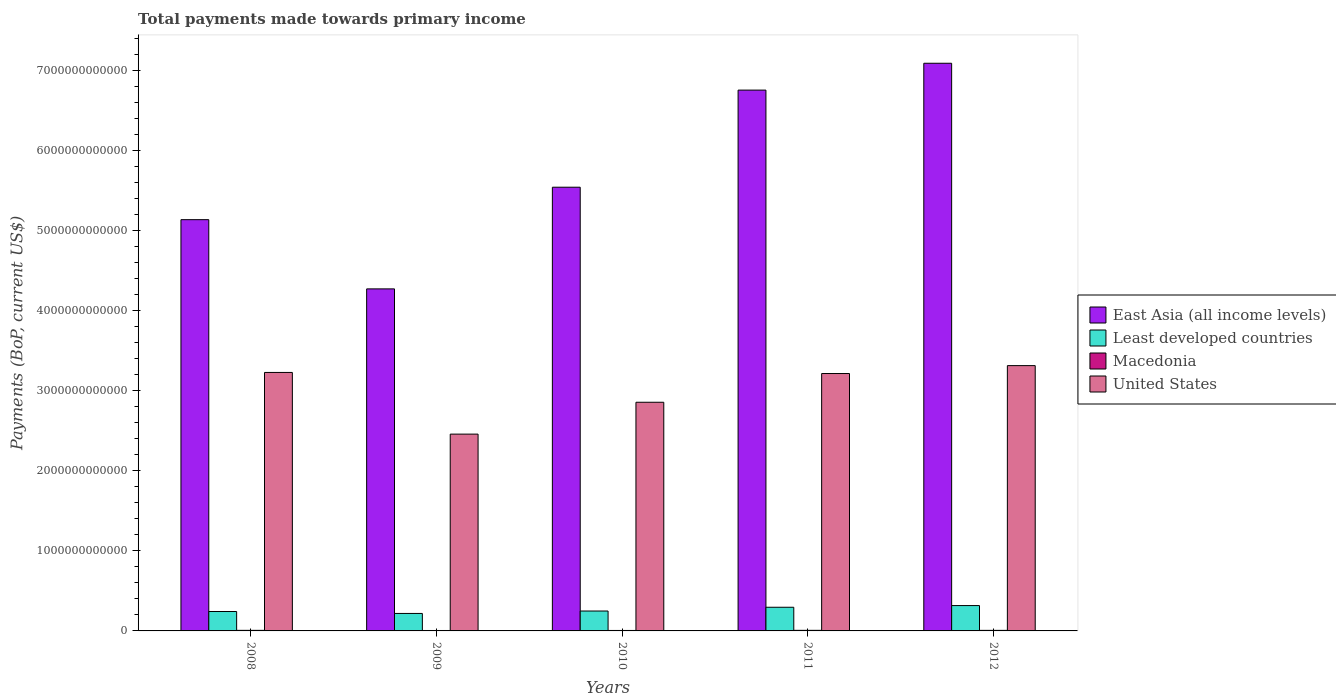Are the number of bars per tick equal to the number of legend labels?
Give a very brief answer. Yes. How many bars are there on the 3rd tick from the left?
Provide a succinct answer. 4. What is the label of the 3rd group of bars from the left?
Give a very brief answer. 2010. What is the total payments made towards primary income in United States in 2012?
Your response must be concise. 3.31e+12. Across all years, what is the maximum total payments made towards primary income in East Asia (all income levels)?
Provide a succinct answer. 7.09e+12. Across all years, what is the minimum total payments made towards primary income in United States?
Ensure brevity in your answer.  2.46e+12. What is the total total payments made towards primary income in East Asia (all income levels) in the graph?
Your answer should be very brief. 2.88e+13. What is the difference between the total payments made towards primary income in East Asia (all income levels) in 2009 and that in 2010?
Offer a very short reply. -1.27e+12. What is the difference between the total payments made towards primary income in United States in 2010 and the total payments made towards primary income in East Asia (all income levels) in 2009?
Give a very brief answer. -1.42e+12. What is the average total payments made towards primary income in United States per year?
Provide a succinct answer. 3.01e+12. In the year 2011, what is the difference between the total payments made towards primary income in Least developed countries and total payments made towards primary income in East Asia (all income levels)?
Offer a very short reply. -6.46e+12. In how many years, is the total payments made towards primary income in United States greater than 4600000000000 US$?
Your answer should be compact. 0. What is the ratio of the total payments made towards primary income in Least developed countries in 2009 to that in 2011?
Make the answer very short. 0.74. Is the total payments made towards primary income in Least developed countries in 2009 less than that in 2012?
Provide a succinct answer. Yes. What is the difference between the highest and the second highest total payments made towards primary income in United States?
Make the answer very short. 8.52e+1. What is the difference between the highest and the lowest total payments made towards primary income in Least developed countries?
Provide a short and direct response. 9.82e+1. Is the sum of the total payments made towards primary income in East Asia (all income levels) in 2008 and 2012 greater than the maximum total payments made towards primary income in Macedonia across all years?
Keep it short and to the point. Yes. Is it the case that in every year, the sum of the total payments made towards primary income in United States and total payments made towards primary income in East Asia (all income levels) is greater than the sum of total payments made towards primary income in Least developed countries and total payments made towards primary income in Macedonia?
Offer a very short reply. No. What does the 1st bar from the left in 2009 represents?
Offer a very short reply. East Asia (all income levels). What does the 4th bar from the right in 2009 represents?
Your answer should be very brief. East Asia (all income levels). Is it the case that in every year, the sum of the total payments made towards primary income in Least developed countries and total payments made towards primary income in Macedonia is greater than the total payments made towards primary income in East Asia (all income levels)?
Ensure brevity in your answer.  No. What is the difference between two consecutive major ticks on the Y-axis?
Your answer should be very brief. 1.00e+12. Are the values on the major ticks of Y-axis written in scientific E-notation?
Offer a very short reply. No. Does the graph contain any zero values?
Provide a succinct answer. No. Does the graph contain grids?
Offer a terse response. No. What is the title of the graph?
Keep it short and to the point. Total payments made towards primary income. Does "East Asia (developing only)" appear as one of the legend labels in the graph?
Keep it short and to the point. No. What is the label or title of the X-axis?
Your response must be concise. Years. What is the label or title of the Y-axis?
Make the answer very short. Payments (BoP, current US$). What is the Payments (BoP, current US$) of East Asia (all income levels) in 2008?
Make the answer very short. 5.14e+12. What is the Payments (BoP, current US$) of Least developed countries in 2008?
Keep it short and to the point. 2.42e+11. What is the Payments (BoP, current US$) of Macedonia in 2008?
Ensure brevity in your answer.  7.21e+09. What is the Payments (BoP, current US$) of United States in 2008?
Give a very brief answer. 3.23e+12. What is the Payments (BoP, current US$) of East Asia (all income levels) in 2009?
Give a very brief answer. 4.27e+12. What is the Payments (BoP, current US$) of Least developed countries in 2009?
Give a very brief answer. 2.18e+11. What is the Payments (BoP, current US$) of Macedonia in 2009?
Your response must be concise. 5.38e+09. What is the Payments (BoP, current US$) of United States in 2009?
Keep it short and to the point. 2.46e+12. What is the Payments (BoP, current US$) in East Asia (all income levels) in 2010?
Keep it short and to the point. 5.54e+12. What is the Payments (BoP, current US$) of Least developed countries in 2010?
Your answer should be very brief. 2.49e+11. What is the Payments (BoP, current US$) in Macedonia in 2010?
Ensure brevity in your answer.  5.79e+09. What is the Payments (BoP, current US$) in United States in 2010?
Offer a terse response. 2.86e+12. What is the Payments (BoP, current US$) in East Asia (all income levels) in 2011?
Offer a terse response. 6.75e+12. What is the Payments (BoP, current US$) in Least developed countries in 2011?
Keep it short and to the point. 2.95e+11. What is the Payments (BoP, current US$) in Macedonia in 2011?
Your answer should be very brief. 7.35e+09. What is the Payments (BoP, current US$) of United States in 2011?
Offer a terse response. 3.21e+12. What is the Payments (BoP, current US$) in East Asia (all income levels) in 2012?
Your answer should be compact. 7.09e+12. What is the Payments (BoP, current US$) of Least developed countries in 2012?
Offer a very short reply. 3.17e+11. What is the Payments (BoP, current US$) in Macedonia in 2012?
Provide a succinct answer. 6.92e+09. What is the Payments (BoP, current US$) of United States in 2012?
Give a very brief answer. 3.31e+12. Across all years, what is the maximum Payments (BoP, current US$) in East Asia (all income levels)?
Keep it short and to the point. 7.09e+12. Across all years, what is the maximum Payments (BoP, current US$) of Least developed countries?
Your answer should be compact. 3.17e+11. Across all years, what is the maximum Payments (BoP, current US$) of Macedonia?
Your response must be concise. 7.35e+09. Across all years, what is the maximum Payments (BoP, current US$) in United States?
Provide a succinct answer. 3.31e+12. Across all years, what is the minimum Payments (BoP, current US$) of East Asia (all income levels)?
Give a very brief answer. 4.27e+12. Across all years, what is the minimum Payments (BoP, current US$) in Least developed countries?
Provide a succinct answer. 2.18e+11. Across all years, what is the minimum Payments (BoP, current US$) in Macedonia?
Your response must be concise. 5.38e+09. Across all years, what is the minimum Payments (BoP, current US$) of United States?
Provide a succinct answer. 2.46e+12. What is the total Payments (BoP, current US$) in East Asia (all income levels) in the graph?
Your answer should be very brief. 2.88e+13. What is the total Payments (BoP, current US$) of Least developed countries in the graph?
Provide a short and direct response. 1.32e+12. What is the total Payments (BoP, current US$) of Macedonia in the graph?
Give a very brief answer. 3.26e+1. What is the total Payments (BoP, current US$) of United States in the graph?
Your answer should be very brief. 1.51e+13. What is the difference between the Payments (BoP, current US$) in East Asia (all income levels) in 2008 and that in 2009?
Make the answer very short. 8.64e+11. What is the difference between the Payments (BoP, current US$) of Least developed countries in 2008 and that in 2009?
Provide a succinct answer. 2.40e+1. What is the difference between the Payments (BoP, current US$) of Macedonia in 2008 and that in 2009?
Offer a very short reply. 1.83e+09. What is the difference between the Payments (BoP, current US$) in United States in 2008 and that in 2009?
Make the answer very short. 7.70e+11. What is the difference between the Payments (BoP, current US$) of East Asia (all income levels) in 2008 and that in 2010?
Ensure brevity in your answer.  -4.05e+11. What is the difference between the Payments (BoP, current US$) in Least developed countries in 2008 and that in 2010?
Offer a terse response. -6.20e+09. What is the difference between the Payments (BoP, current US$) of Macedonia in 2008 and that in 2010?
Make the answer very short. 1.42e+09. What is the difference between the Payments (BoP, current US$) in United States in 2008 and that in 2010?
Ensure brevity in your answer.  3.72e+11. What is the difference between the Payments (BoP, current US$) in East Asia (all income levels) in 2008 and that in 2011?
Make the answer very short. -1.62e+12. What is the difference between the Payments (BoP, current US$) of Least developed countries in 2008 and that in 2011?
Your answer should be compact. -5.31e+1. What is the difference between the Payments (BoP, current US$) in Macedonia in 2008 and that in 2011?
Ensure brevity in your answer.  -1.41e+08. What is the difference between the Payments (BoP, current US$) of United States in 2008 and that in 2011?
Your answer should be very brief. 1.35e+1. What is the difference between the Payments (BoP, current US$) of East Asia (all income levels) in 2008 and that in 2012?
Offer a very short reply. -1.95e+12. What is the difference between the Payments (BoP, current US$) in Least developed countries in 2008 and that in 2012?
Offer a terse response. -7.42e+1. What is the difference between the Payments (BoP, current US$) in Macedonia in 2008 and that in 2012?
Your answer should be compact. 2.89e+08. What is the difference between the Payments (BoP, current US$) of United States in 2008 and that in 2012?
Provide a succinct answer. -8.52e+1. What is the difference between the Payments (BoP, current US$) in East Asia (all income levels) in 2009 and that in 2010?
Your response must be concise. -1.27e+12. What is the difference between the Payments (BoP, current US$) in Least developed countries in 2009 and that in 2010?
Your answer should be very brief. -3.02e+1. What is the difference between the Payments (BoP, current US$) in Macedonia in 2009 and that in 2010?
Your response must be concise. -4.10e+08. What is the difference between the Payments (BoP, current US$) in United States in 2009 and that in 2010?
Make the answer very short. -3.98e+11. What is the difference between the Payments (BoP, current US$) of East Asia (all income levels) in 2009 and that in 2011?
Offer a terse response. -2.48e+12. What is the difference between the Payments (BoP, current US$) in Least developed countries in 2009 and that in 2011?
Provide a succinct answer. -7.71e+1. What is the difference between the Payments (BoP, current US$) of Macedonia in 2009 and that in 2011?
Provide a succinct answer. -1.97e+09. What is the difference between the Payments (BoP, current US$) in United States in 2009 and that in 2011?
Provide a short and direct response. -7.57e+11. What is the difference between the Payments (BoP, current US$) of East Asia (all income levels) in 2009 and that in 2012?
Offer a terse response. -2.82e+12. What is the difference between the Payments (BoP, current US$) in Least developed countries in 2009 and that in 2012?
Keep it short and to the point. -9.82e+1. What is the difference between the Payments (BoP, current US$) in Macedonia in 2009 and that in 2012?
Your response must be concise. -1.54e+09. What is the difference between the Payments (BoP, current US$) of United States in 2009 and that in 2012?
Make the answer very short. -8.55e+11. What is the difference between the Payments (BoP, current US$) in East Asia (all income levels) in 2010 and that in 2011?
Ensure brevity in your answer.  -1.21e+12. What is the difference between the Payments (BoP, current US$) of Least developed countries in 2010 and that in 2011?
Keep it short and to the point. -4.69e+1. What is the difference between the Payments (BoP, current US$) of Macedonia in 2010 and that in 2011?
Your response must be concise. -1.56e+09. What is the difference between the Payments (BoP, current US$) in United States in 2010 and that in 2011?
Provide a short and direct response. -3.59e+11. What is the difference between the Payments (BoP, current US$) of East Asia (all income levels) in 2010 and that in 2012?
Provide a short and direct response. -1.55e+12. What is the difference between the Payments (BoP, current US$) in Least developed countries in 2010 and that in 2012?
Keep it short and to the point. -6.80e+1. What is the difference between the Payments (BoP, current US$) in Macedonia in 2010 and that in 2012?
Make the answer very short. -1.13e+09. What is the difference between the Payments (BoP, current US$) in United States in 2010 and that in 2012?
Ensure brevity in your answer.  -4.58e+11. What is the difference between the Payments (BoP, current US$) in East Asia (all income levels) in 2011 and that in 2012?
Keep it short and to the point. -3.35e+11. What is the difference between the Payments (BoP, current US$) in Least developed countries in 2011 and that in 2012?
Your answer should be compact. -2.11e+1. What is the difference between the Payments (BoP, current US$) in Macedonia in 2011 and that in 2012?
Your answer should be compact. 4.29e+08. What is the difference between the Payments (BoP, current US$) of United States in 2011 and that in 2012?
Ensure brevity in your answer.  -9.86e+1. What is the difference between the Payments (BoP, current US$) in East Asia (all income levels) in 2008 and the Payments (BoP, current US$) in Least developed countries in 2009?
Give a very brief answer. 4.92e+12. What is the difference between the Payments (BoP, current US$) of East Asia (all income levels) in 2008 and the Payments (BoP, current US$) of Macedonia in 2009?
Your response must be concise. 5.13e+12. What is the difference between the Payments (BoP, current US$) in East Asia (all income levels) in 2008 and the Payments (BoP, current US$) in United States in 2009?
Your answer should be very brief. 2.68e+12. What is the difference between the Payments (BoP, current US$) of Least developed countries in 2008 and the Payments (BoP, current US$) of Macedonia in 2009?
Offer a terse response. 2.37e+11. What is the difference between the Payments (BoP, current US$) of Least developed countries in 2008 and the Payments (BoP, current US$) of United States in 2009?
Offer a terse response. -2.22e+12. What is the difference between the Payments (BoP, current US$) in Macedonia in 2008 and the Payments (BoP, current US$) in United States in 2009?
Provide a succinct answer. -2.45e+12. What is the difference between the Payments (BoP, current US$) in East Asia (all income levels) in 2008 and the Payments (BoP, current US$) in Least developed countries in 2010?
Give a very brief answer. 4.89e+12. What is the difference between the Payments (BoP, current US$) in East Asia (all income levels) in 2008 and the Payments (BoP, current US$) in Macedonia in 2010?
Offer a very short reply. 5.13e+12. What is the difference between the Payments (BoP, current US$) in East Asia (all income levels) in 2008 and the Payments (BoP, current US$) in United States in 2010?
Ensure brevity in your answer.  2.28e+12. What is the difference between the Payments (BoP, current US$) of Least developed countries in 2008 and the Payments (BoP, current US$) of Macedonia in 2010?
Provide a short and direct response. 2.37e+11. What is the difference between the Payments (BoP, current US$) of Least developed countries in 2008 and the Payments (BoP, current US$) of United States in 2010?
Offer a terse response. -2.61e+12. What is the difference between the Payments (BoP, current US$) in Macedonia in 2008 and the Payments (BoP, current US$) in United States in 2010?
Your answer should be compact. -2.85e+12. What is the difference between the Payments (BoP, current US$) of East Asia (all income levels) in 2008 and the Payments (BoP, current US$) of Least developed countries in 2011?
Your response must be concise. 4.84e+12. What is the difference between the Payments (BoP, current US$) in East Asia (all income levels) in 2008 and the Payments (BoP, current US$) in Macedonia in 2011?
Your answer should be compact. 5.13e+12. What is the difference between the Payments (BoP, current US$) in East Asia (all income levels) in 2008 and the Payments (BoP, current US$) in United States in 2011?
Your answer should be very brief. 1.92e+12. What is the difference between the Payments (BoP, current US$) of Least developed countries in 2008 and the Payments (BoP, current US$) of Macedonia in 2011?
Your response must be concise. 2.35e+11. What is the difference between the Payments (BoP, current US$) in Least developed countries in 2008 and the Payments (BoP, current US$) in United States in 2011?
Offer a terse response. -2.97e+12. What is the difference between the Payments (BoP, current US$) of Macedonia in 2008 and the Payments (BoP, current US$) of United States in 2011?
Keep it short and to the point. -3.21e+12. What is the difference between the Payments (BoP, current US$) in East Asia (all income levels) in 2008 and the Payments (BoP, current US$) in Least developed countries in 2012?
Your answer should be compact. 4.82e+12. What is the difference between the Payments (BoP, current US$) in East Asia (all income levels) in 2008 and the Payments (BoP, current US$) in Macedonia in 2012?
Provide a short and direct response. 5.13e+12. What is the difference between the Payments (BoP, current US$) of East Asia (all income levels) in 2008 and the Payments (BoP, current US$) of United States in 2012?
Keep it short and to the point. 1.82e+12. What is the difference between the Payments (BoP, current US$) in Least developed countries in 2008 and the Payments (BoP, current US$) in Macedonia in 2012?
Your answer should be compact. 2.35e+11. What is the difference between the Payments (BoP, current US$) in Least developed countries in 2008 and the Payments (BoP, current US$) in United States in 2012?
Your answer should be very brief. -3.07e+12. What is the difference between the Payments (BoP, current US$) in Macedonia in 2008 and the Payments (BoP, current US$) in United States in 2012?
Provide a succinct answer. -3.31e+12. What is the difference between the Payments (BoP, current US$) of East Asia (all income levels) in 2009 and the Payments (BoP, current US$) of Least developed countries in 2010?
Your response must be concise. 4.02e+12. What is the difference between the Payments (BoP, current US$) of East Asia (all income levels) in 2009 and the Payments (BoP, current US$) of Macedonia in 2010?
Make the answer very short. 4.27e+12. What is the difference between the Payments (BoP, current US$) of East Asia (all income levels) in 2009 and the Payments (BoP, current US$) of United States in 2010?
Offer a very short reply. 1.42e+12. What is the difference between the Payments (BoP, current US$) of Least developed countries in 2009 and the Payments (BoP, current US$) of Macedonia in 2010?
Keep it short and to the point. 2.13e+11. What is the difference between the Payments (BoP, current US$) in Least developed countries in 2009 and the Payments (BoP, current US$) in United States in 2010?
Offer a terse response. -2.64e+12. What is the difference between the Payments (BoP, current US$) of Macedonia in 2009 and the Payments (BoP, current US$) of United States in 2010?
Offer a terse response. -2.85e+12. What is the difference between the Payments (BoP, current US$) in East Asia (all income levels) in 2009 and the Payments (BoP, current US$) in Least developed countries in 2011?
Your response must be concise. 3.98e+12. What is the difference between the Payments (BoP, current US$) in East Asia (all income levels) in 2009 and the Payments (BoP, current US$) in Macedonia in 2011?
Offer a terse response. 4.26e+12. What is the difference between the Payments (BoP, current US$) of East Asia (all income levels) in 2009 and the Payments (BoP, current US$) of United States in 2011?
Give a very brief answer. 1.06e+12. What is the difference between the Payments (BoP, current US$) of Least developed countries in 2009 and the Payments (BoP, current US$) of Macedonia in 2011?
Give a very brief answer. 2.11e+11. What is the difference between the Payments (BoP, current US$) of Least developed countries in 2009 and the Payments (BoP, current US$) of United States in 2011?
Offer a terse response. -3.00e+12. What is the difference between the Payments (BoP, current US$) in Macedonia in 2009 and the Payments (BoP, current US$) in United States in 2011?
Offer a terse response. -3.21e+12. What is the difference between the Payments (BoP, current US$) of East Asia (all income levels) in 2009 and the Payments (BoP, current US$) of Least developed countries in 2012?
Keep it short and to the point. 3.95e+12. What is the difference between the Payments (BoP, current US$) in East Asia (all income levels) in 2009 and the Payments (BoP, current US$) in Macedonia in 2012?
Your answer should be compact. 4.26e+12. What is the difference between the Payments (BoP, current US$) in East Asia (all income levels) in 2009 and the Payments (BoP, current US$) in United States in 2012?
Make the answer very short. 9.58e+11. What is the difference between the Payments (BoP, current US$) in Least developed countries in 2009 and the Payments (BoP, current US$) in Macedonia in 2012?
Offer a terse response. 2.11e+11. What is the difference between the Payments (BoP, current US$) in Least developed countries in 2009 and the Payments (BoP, current US$) in United States in 2012?
Ensure brevity in your answer.  -3.09e+12. What is the difference between the Payments (BoP, current US$) in Macedonia in 2009 and the Payments (BoP, current US$) in United States in 2012?
Your response must be concise. -3.31e+12. What is the difference between the Payments (BoP, current US$) of East Asia (all income levels) in 2010 and the Payments (BoP, current US$) of Least developed countries in 2011?
Provide a succinct answer. 5.25e+12. What is the difference between the Payments (BoP, current US$) in East Asia (all income levels) in 2010 and the Payments (BoP, current US$) in Macedonia in 2011?
Your response must be concise. 5.53e+12. What is the difference between the Payments (BoP, current US$) of East Asia (all income levels) in 2010 and the Payments (BoP, current US$) of United States in 2011?
Keep it short and to the point. 2.33e+12. What is the difference between the Payments (BoP, current US$) in Least developed countries in 2010 and the Payments (BoP, current US$) in Macedonia in 2011?
Offer a terse response. 2.41e+11. What is the difference between the Payments (BoP, current US$) in Least developed countries in 2010 and the Payments (BoP, current US$) in United States in 2011?
Your answer should be compact. -2.97e+12. What is the difference between the Payments (BoP, current US$) in Macedonia in 2010 and the Payments (BoP, current US$) in United States in 2011?
Offer a very short reply. -3.21e+12. What is the difference between the Payments (BoP, current US$) in East Asia (all income levels) in 2010 and the Payments (BoP, current US$) in Least developed countries in 2012?
Provide a short and direct response. 5.22e+12. What is the difference between the Payments (BoP, current US$) in East Asia (all income levels) in 2010 and the Payments (BoP, current US$) in Macedonia in 2012?
Provide a short and direct response. 5.53e+12. What is the difference between the Payments (BoP, current US$) of East Asia (all income levels) in 2010 and the Payments (BoP, current US$) of United States in 2012?
Your answer should be compact. 2.23e+12. What is the difference between the Payments (BoP, current US$) in Least developed countries in 2010 and the Payments (BoP, current US$) in Macedonia in 2012?
Provide a short and direct response. 2.42e+11. What is the difference between the Payments (BoP, current US$) in Least developed countries in 2010 and the Payments (BoP, current US$) in United States in 2012?
Your response must be concise. -3.06e+12. What is the difference between the Payments (BoP, current US$) in Macedonia in 2010 and the Payments (BoP, current US$) in United States in 2012?
Offer a very short reply. -3.31e+12. What is the difference between the Payments (BoP, current US$) of East Asia (all income levels) in 2011 and the Payments (BoP, current US$) of Least developed countries in 2012?
Give a very brief answer. 6.44e+12. What is the difference between the Payments (BoP, current US$) in East Asia (all income levels) in 2011 and the Payments (BoP, current US$) in Macedonia in 2012?
Your answer should be compact. 6.75e+12. What is the difference between the Payments (BoP, current US$) in East Asia (all income levels) in 2011 and the Payments (BoP, current US$) in United States in 2012?
Offer a terse response. 3.44e+12. What is the difference between the Payments (BoP, current US$) in Least developed countries in 2011 and the Payments (BoP, current US$) in Macedonia in 2012?
Provide a succinct answer. 2.89e+11. What is the difference between the Payments (BoP, current US$) of Least developed countries in 2011 and the Payments (BoP, current US$) of United States in 2012?
Give a very brief answer. -3.02e+12. What is the difference between the Payments (BoP, current US$) of Macedonia in 2011 and the Payments (BoP, current US$) of United States in 2012?
Your answer should be very brief. -3.31e+12. What is the average Payments (BoP, current US$) in East Asia (all income levels) per year?
Make the answer very short. 5.76e+12. What is the average Payments (BoP, current US$) in Least developed countries per year?
Provide a short and direct response. 2.64e+11. What is the average Payments (BoP, current US$) in Macedonia per year?
Your response must be concise. 6.53e+09. What is the average Payments (BoP, current US$) in United States per year?
Offer a very short reply. 3.01e+12. In the year 2008, what is the difference between the Payments (BoP, current US$) in East Asia (all income levels) and Payments (BoP, current US$) in Least developed countries?
Provide a succinct answer. 4.89e+12. In the year 2008, what is the difference between the Payments (BoP, current US$) in East Asia (all income levels) and Payments (BoP, current US$) in Macedonia?
Give a very brief answer. 5.13e+12. In the year 2008, what is the difference between the Payments (BoP, current US$) of East Asia (all income levels) and Payments (BoP, current US$) of United States?
Offer a very short reply. 1.91e+12. In the year 2008, what is the difference between the Payments (BoP, current US$) in Least developed countries and Payments (BoP, current US$) in Macedonia?
Give a very brief answer. 2.35e+11. In the year 2008, what is the difference between the Payments (BoP, current US$) of Least developed countries and Payments (BoP, current US$) of United States?
Offer a very short reply. -2.99e+12. In the year 2008, what is the difference between the Payments (BoP, current US$) in Macedonia and Payments (BoP, current US$) in United States?
Provide a succinct answer. -3.22e+12. In the year 2009, what is the difference between the Payments (BoP, current US$) in East Asia (all income levels) and Payments (BoP, current US$) in Least developed countries?
Make the answer very short. 4.05e+12. In the year 2009, what is the difference between the Payments (BoP, current US$) of East Asia (all income levels) and Payments (BoP, current US$) of Macedonia?
Provide a succinct answer. 4.27e+12. In the year 2009, what is the difference between the Payments (BoP, current US$) of East Asia (all income levels) and Payments (BoP, current US$) of United States?
Make the answer very short. 1.81e+12. In the year 2009, what is the difference between the Payments (BoP, current US$) of Least developed countries and Payments (BoP, current US$) of Macedonia?
Your response must be concise. 2.13e+11. In the year 2009, what is the difference between the Payments (BoP, current US$) of Least developed countries and Payments (BoP, current US$) of United States?
Keep it short and to the point. -2.24e+12. In the year 2009, what is the difference between the Payments (BoP, current US$) of Macedonia and Payments (BoP, current US$) of United States?
Provide a succinct answer. -2.45e+12. In the year 2010, what is the difference between the Payments (BoP, current US$) in East Asia (all income levels) and Payments (BoP, current US$) in Least developed countries?
Your response must be concise. 5.29e+12. In the year 2010, what is the difference between the Payments (BoP, current US$) in East Asia (all income levels) and Payments (BoP, current US$) in Macedonia?
Your answer should be very brief. 5.54e+12. In the year 2010, what is the difference between the Payments (BoP, current US$) in East Asia (all income levels) and Payments (BoP, current US$) in United States?
Give a very brief answer. 2.69e+12. In the year 2010, what is the difference between the Payments (BoP, current US$) of Least developed countries and Payments (BoP, current US$) of Macedonia?
Provide a succinct answer. 2.43e+11. In the year 2010, what is the difference between the Payments (BoP, current US$) in Least developed countries and Payments (BoP, current US$) in United States?
Your response must be concise. -2.61e+12. In the year 2010, what is the difference between the Payments (BoP, current US$) in Macedonia and Payments (BoP, current US$) in United States?
Provide a short and direct response. -2.85e+12. In the year 2011, what is the difference between the Payments (BoP, current US$) of East Asia (all income levels) and Payments (BoP, current US$) of Least developed countries?
Make the answer very short. 6.46e+12. In the year 2011, what is the difference between the Payments (BoP, current US$) in East Asia (all income levels) and Payments (BoP, current US$) in Macedonia?
Your answer should be compact. 6.75e+12. In the year 2011, what is the difference between the Payments (BoP, current US$) in East Asia (all income levels) and Payments (BoP, current US$) in United States?
Keep it short and to the point. 3.54e+12. In the year 2011, what is the difference between the Payments (BoP, current US$) of Least developed countries and Payments (BoP, current US$) of Macedonia?
Offer a very short reply. 2.88e+11. In the year 2011, what is the difference between the Payments (BoP, current US$) in Least developed countries and Payments (BoP, current US$) in United States?
Make the answer very short. -2.92e+12. In the year 2011, what is the difference between the Payments (BoP, current US$) of Macedonia and Payments (BoP, current US$) of United States?
Offer a very short reply. -3.21e+12. In the year 2012, what is the difference between the Payments (BoP, current US$) in East Asia (all income levels) and Payments (BoP, current US$) in Least developed countries?
Provide a succinct answer. 6.77e+12. In the year 2012, what is the difference between the Payments (BoP, current US$) of East Asia (all income levels) and Payments (BoP, current US$) of Macedonia?
Keep it short and to the point. 7.08e+12. In the year 2012, what is the difference between the Payments (BoP, current US$) of East Asia (all income levels) and Payments (BoP, current US$) of United States?
Offer a very short reply. 3.78e+12. In the year 2012, what is the difference between the Payments (BoP, current US$) of Least developed countries and Payments (BoP, current US$) of Macedonia?
Your response must be concise. 3.10e+11. In the year 2012, what is the difference between the Payments (BoP, current US$) of Least developed countries and Payments (BoP, current US$) of United States?
Provide a succinct answer. -3.00e+12. In the year 2012, what is the difference between the Payments (BoP, current US$) of Macedonia and Payments (BoP, current US$) of United States?
Your response must be concise. -3.31e+12. What is the ratio of the Payments (BoP, current US$) of East Asia (all income levels) in 2008 to that in 2009?
Offer a very short reply. 1.2. What is the ratio of the Payments (BoP, current US$) in Least developed countries in 2008 to that in 2009?
Offer a terse response. 1.11. What is the ratio of the Payments (BoP, current US$) in Macedonia in 2008 to that in 2009?
Provide a short and direct response. 1.34. What is the ratio of the Payments (BoP, current US$) in United States in 2008 to that in 2009?
Provide a succinct answer. 1.31. What is the ratio of the Payments (BoP, current US$) of East Asia (all income levels) in 2008 to that in 2010?
Ensure brevity in your answer.  0.93. What is the ratio of the Payments (BoP, current US$) of Least developed countries in 2008 to that in 2010?
Your answer should be compact. 0.97. What is the ratio of the Payments (BoP, current US$) of Macedonia in 2008 to that in 2010?
Your answer should be compact. 1.24. What is the ratio of the Payments (BoP, current US$) in United States in 2008 to that in 2010?
Provide a short and direct response. 1.13. What is the ratio of the Payments (BoP, current US$) in East Asia (all income levels) in 2008 to that in 2011?
Offer a terse response. 0.76. What is the ratio of the Payments (BoP, current US$) of Least developed countries in 2008 to that in 2011?
Ensure brevity in your answer.  0.82. What is the ratio of the Payments (BoP, current US$) in Macedonia in 2008 to that in 2011?
Provide a short and direct response. 0.98. What is the ratio of the Payments (BoP, current US$) of United States in 2008 to that in 2011?
Offer a very short reply. 1. What is the ratio of the Payments (BoP, current US$) of East Asia (all income levels) in 2008 to that in 2012?
Give a very brief answer. 0.72. What is the ratio of the Payments (BoP, current US$) of Least developed countries in 2008 to that in 2012?
Offer a very short reply. 0.77. What is the ratio of the Payments (BoP, current US$) of Macedonia in 2008 to that in 2012?
Your response must be concise. 1.04. What is the ratio of the Payments (BoP, current US$) in United States in 2008 to that in 2012?
Offer a terse response. 0.97. What is the ratio of the Payments (BoP, current US$) of East Asia (all income levels) in 2009 to that in 2010?
Your answer should be compact. 0.77. What is the ratio of the Payments (BoP, current US$) in Least developed countries in 2009 to that in 2010?
Your answer should be compact. 0.88. What is the ratio of the Payments (BoP, current US$) of Macedonia in 2009 to that in 2010?
Keep it short and to the point. 0.93. What is the ratio of the Payments (BoP, current US$) in United States in 2009 to that in 2010?
Give a very brief answer. 0.86. What is the ratio of the Payments (BoP, current US$) in East Asia (all income levels) in 2009 to that in 2011?
Make the answer very short. 0.63. What is the ratio of the Payments (BoP, current US$) in Least developed countries in 2009 to that in 2011?
Give a very brief answer. 0.74. What is the ratio of the Payments (BoP, current US$) of Macedonia in 2009 to that in 2011?
Offer a terse response. 0.73. What is the ratio of the Payments (BoP, current US$) of United States in 2009 to that in 2011?
Provide a short and direct response. 0.76. What is the ratio of the Payments (BoP, current US$) of East Asia (all income levels) in 2009 to that in 2012?
Offer a very short reply. 0.6. What is the ratio of the Payments (BoP, current US$) of Least developed countries in 2009 to that in 2012?
Your answer should be compact. 0.69. What is the ratio of the Payments (BoP, current US$) in Macedonia in 2009 to that in 2012?
Provide a succinct answer. 0.78. What is the ratio of the Payments (BoP, current US$) of United States in 2009 to that in 2012?
Your answer should be very brief. 0.74. What is the ratio of the Payments (BoP, current US$) in East Asia (all income levels) in 2010 to that in 2011?
Your answer should be very brief. 0.82. What is the ratio of the Payments (BoP, current US$) of Least developed countries in 2010 to that in 2011?
Offer a terse response. 0.84. What is the ratio of the Payments (BoP, current US$) in Macedonia in 2010 to that in 2011?
Provide a short and direct response. 0.79. What is the ratio of the Payments (BoP, current US$) in United States in 2010 to that in 2011?
Your answer should be compact. 0.89. What is the ratio of the Payments (BoP, current US$) in East Asia (all income levels) in 2010 to that in 2012?
Provide a succinct answer. 0.78. What is the ratio of the Payments (BoP, current US$) of Least developed countries in 2010 to that in 2012?
Make the answer very short. 0.79. What is the ratio of the Payments (BoP, current US$) in Macedonia in 2010 to that in 2012?
Offer a very short reply. 0.84. What is the ratio of the Payments (BoP, current US$) of United States in 2010 to that in 2012?
Make the answer very short. 0.86. What is the ratio of the Payments (BoP, current US$) of East Asia (all income levels) in 2011 to that in 2012?
Ensure brevity in your answer.  0.95. What is the ratio of the Payments (BoP, current US$) of Macedonia in 2011 to that in 2012?
Make the answer very short. 1.06. What is the ratio of the Payments (BoP, current US$) of United States in 2011 to that in 2012?
Offer a very short reply. 0.97. What is the difference between the highest and the second highest Payments (BoP, current US$) in East Asia (all income levels)?
Your answer should be compact. 3.35e+11. What is the difference between the highest and the second highest Payments (BoP, current US$) in Least developed countries?
Ensure brevity in your answer.  2.11e+1. What is the difference between the highest and the second highest Payments (BoP, current US$) in Macedonia?
Provide a succinct answer. 1.41e+08. What is the difference between the highest and the second highest Payments (BoP, current US$) of United States?
Give a very brief answer. 8.52e+1. What is the difference between the highest and the lowest Payments (BoP, current US$) in East Asia (all income levels)?
Your answer should be compact. 2.82e+12. What is the difference between the highest and the lowest Payments (BoP, current US$) in Least developed countries?
Your response must be concise. 9.82e+1. What is the difference between the highest and the lowest Payments (BoP, current US$) in Macedonia?
Keep it short and to the point. 1.97e+09. What is the difference between the highest and the lowest Payments (BoP, current US$) of United States?
Your response must be concise. 8.55e+11. 